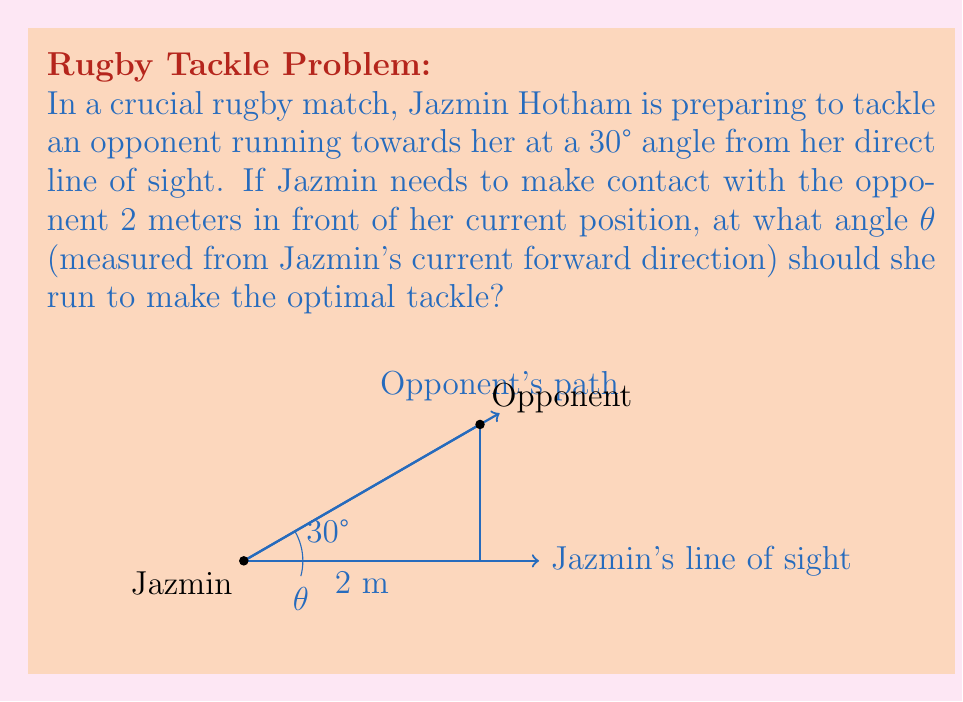Teach me how to tackle this problem. To solve this problem, we'll use trigonometric functions in the triangle formed by Jazmin's current position, her tackle point, and the opponent's position.

1) Let's define our triangle:
   - The base of the triangle is 2 meters (the distance Jazmin needs to run forward).
   - The angle between the base and the opponent's path is 30°.
   - We need to find the angle θ.

2) We can use the tangent function to relate the angle θ to the sides of the triangle:

   $$\tan(\theta) = \frac{\text{opposite}}{\text{adjacent}}$$

3) The opposite side is the perpendicular distance from the opponent's path to Jazmin's forward line. We can find this using:

   $$\text{opposite} = 2 \cdot \sin(30°)$$

4) The adjacent side is the 2-meter distance Jazmin needs to run forward.

5) Substituting these into our tangent equation:

   $$\tan(\theta) = \frac{2 \cdot \sin(30°)}{2}$$

6) Simplify:

   $$\tan(\theta) = \sin(30°) = \frac{1}{2}$$

7) To find θ, we need to use the inverse tangent (arctan or tan^(-1)):

   $$\theta = \arctan(\frac{1}{2})$$

8) Calculate this value:

   $$\theta \approx 26.57°$$

This angle will allow Jazmin to meet the opponent at the optimal point for a tackle, considering the opponent's angle of approach and the distance Jazmin needs to cover.
Answer: $\theta \approx 26.57°$ 